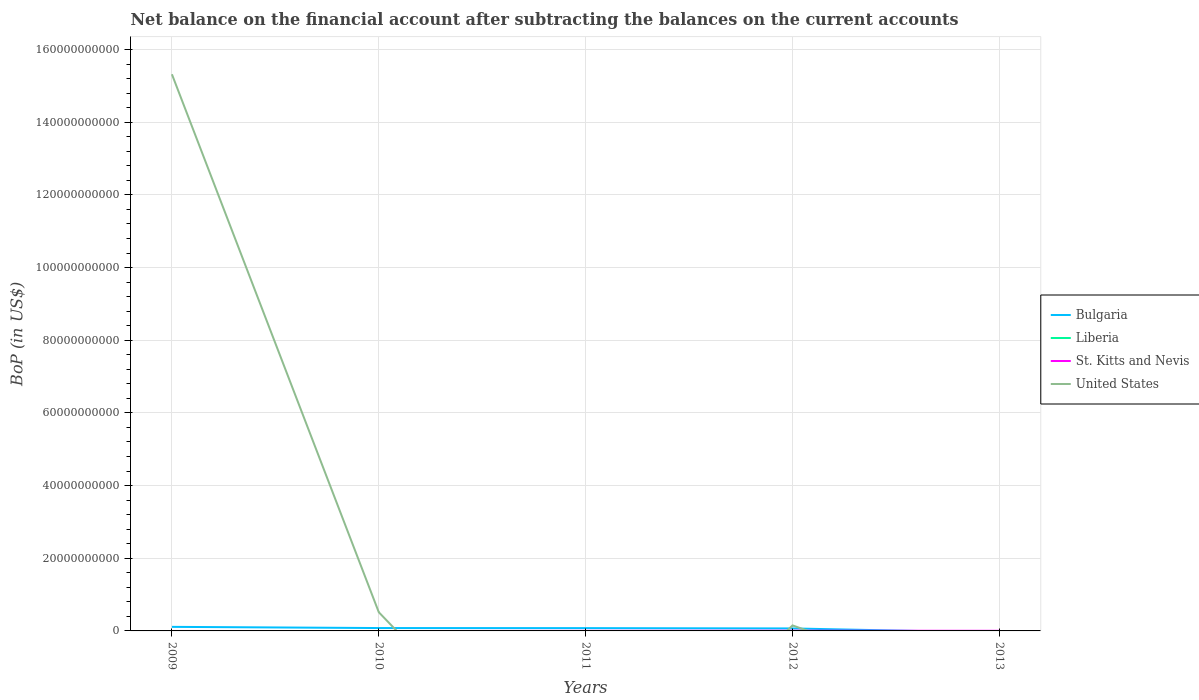How many different coloured lines are there?
Provide a short and direct response. 3. Is the number of lines equal to the number of legend labels?
Provide a succinct answer. No. What is the total Balance of Payments in Bulgaria in the graph?
Your response must be concise. 1.83e+07. What is the difference between the highest and the second highest Balance of Payments in United States?
Give a very brief answer. 1.53e+11. What is the difference between the highest and the lowest Balance of Payments in Liberia?
Offer a terse response. 0. Is the Balance of Payments in St. Kitts and Nevis strictly greater than the Balance of Payments in United States over the years?
Make the answer very short. No. How many lines are there?
Ensure brevity in your answer.  3. How many years are there in the graph?
Your answer should be very brief. 5. What is the difference between two consecutive major ticks on the Y-axis?
Make the answer very short. 2.00e+1. Does the graph contain any zero values?
Offer a very short reply. Yes. Where does the legend appear in the graph?
Ensure brevity in your answer.  Center right. How are the legend labels stacked?
Your answer should be compact. Vertical. What is the title of the graph?
Your answer should be compact. Net balance on the financial account after subtracting the balances on the current accounts. What is the label or title of the Y-axis?
Provide a short and direct response. BoP (in US$). What is the BoP (in US$) in Bulgaria in 2009?
Make the answer very short. 1.12e+09. What is the BoP (in US$) of Liberia in 2009?
Your answer should be very brief. 0. What is the BoP (in US$) in United States in 2009?
Your response must be concise. 1.53e+11. What is the BoP (in US$) in Bulgaria in 2010?
Make the answer very short. 7.89e+08. What is the BoP (in US$) of Liberia in 2010?
Ensure brevity in your answer.  0. What is the BoP (in US$) in United States in 2010?
Offer a very short reply. 5.15e+09. What is the BoP (in US$) of Bulgaria in 2011?
Provide a short and direct response. 7.71e+08. What is the BoP (in US$) of Liberia in 2011?
Ensure brevity in your answer.  0. What is the BoP (in US$) of St. Kitts and Nevis in 2011?
Your answer should be compact. 1.53e+07. What is the BoP (in US$) in Bulgaria in 2012?
Ensure brevity in your answer.  6.83e+08. What is the BoP (in US$) of St. Kitts and Nevis in 2012?
Ensure brevity in your answer.  5.53e+07. What is the BoP (in US$) of United States in 2012?
Provide a succinct answer. 1.52e+09. What is the BoP (in US$) of Bulgaria in 2013?
Provide a succinct answer. 0. What is the BoP (in US$) in Liberia in 2013?
Make the answer very short. 0. What is the BoP (in US$) in St. Kitts and Nevis in 2013?
Provide a short and direct response. 3.61e+07. Across all years, what is the maximum BoP (in US$) in Bulgaria?
Offer a terse response. 1.12e+09. Across all years, what is the maximum BoP (in US$) of St. Kitts and Nevis?
Give a very brief answer. 5.53e+07. Across all years, what is the maximum BoP (in US$) of United States?
Offer a very short reply. 1.53e+11. Across all years, what is the minimum BoP (in US$) in St. Kitts and Nevis?
Give a very brief answer. 0. What is the total BoP (in US$) in Bulgaria in the graph?
Offer a very short reply. 3.36e+09. What is the total BoP (in US$) of Liberia in the graph?
Ensure brevity in your answer.  0. What is the total BoP (in US$) of St. Kitts and Nevis in the graph?
Ensure brevity in your answer.  1.07e+08. What is the total BoP (in US$) of United States in the graph?
Offer a very short reply. 1.60e+11. What is the difference between the BoP (in US$) of Bulgaria in 2009 and that in 2010?
Give a very brief answer. 3.29e+08. What is the difference between the BoP (in US$) of United States in 2009 and that in 2010?
Give a very brief answer. 1.48e+11. What is the difference between the BoP (in US$) of Bulgaria in 2009 and that in 2011?
Your answer should be compact. 3.48e+08. What is the difference between the BoP (in US$) in Bulgaria in 2009 and that in 2012?
Ensure brevity in your answer.  4.35e+08. What is the difference between the BoP (in US$) in United States in 2009 and that in 2012?
Give a very brief answer. 1.52e+11. What is the difference between the BoP (in US$) of Bulgaria in 2010 and that in 2011?
Your answer should be compact. 1.83e+07. What is the difference between the BoP (in US$) in Bulgaria in 2010 and that in 2012?
Your response must be concise. 1.06e+08. What is the difference between the BoP (in US$) in United States in 2010 and that in 2012?
Your answer should be compact. 3.63e+09. What is the difference between the BoP (in US$) in Bulgaria in 2011 and that in 2012?
Your response must be concise. 8.74e+07. What is the difference between the BoP (in US$) of St. Kitts and Nevis in 2011 and that in 2012?
Offer a terse response. -4.00e+07. What is the difference between the BoP (in US$) in St. Kitts and Nevis in 2011 and that in 2013?
Give a very brief answer. -2.08e+07. What is the difference between the BoP (in US$) in St. Kitts and Nevis in 2012 and that in 2013?
Provide a short and direct response. 1.92e+07. What is the difference between the BoP (in US$) in Bulgaria in 2009 and the BoP (in US$) in United States in 2010?
Your answer should be compact. -4.03e+09. What is the difference between the BoP (in US$) of Bulgaria in 2009 and the BoP (in US$) of St. Kitts and Nevis in 2011?
Ensure brevity in your answer.  1.10e+09. What is the difference between the BoP (in US$) in Bulgaria in 2009 and the BoP (in US$) in St. Kitts and Nevis in 2012?
Provide a succinct answer. 1.06e+09. What is the difference between the BoP (in US$) of Bulgaria in 2009 and the BoP (in US$) of United States in 2012?
Offer a very short reply. -3.99e+08. What is the difference between the BoP (in US$) of Bulgaria in 2009 and the BoP (in US$) of St. Kitts and Nevis in 2013?
Your answer should be very brief. 1.08e+09. What is the difference between the BoP (in US$) of Bulgaria in 2010 and the BoP (in US$) of St. Kitts and Nevis in 2011?
Your response must be concise. 7.74e+08. What is the difference between the BoP (in US$) in Bulgaria in 2010 and the BoP (in US$) in St. Kitts and Nevis in 2012?
Make the answer very short. 7.34e+08. What is the difference between the BoP (in US$) of Bulgaria in 2010 and the BoP (in US$) of United States in 2012?
Your answer should be very brief. -7.28e+08. What is the difference between the BoP (in US$) of Bulgaria in 2010 and the BoP (in US$) of St. Kitts and Nevis in 2013?
Offer a very short reply. 7.53e+08. What is the difference between the BoP (in US$) of Bulgaria in 2011 and the BoP (in US$) of St. Kitts and Nevis in 2012?
Keep it short and to the point. 7.15e+08. What is the difference between the BoP (in US$) of Bulgaria in 2011 and the BoP (in US$) of United States in 2012?
Your answer should be very brief. -7.46e+08. What is the difference between the BoP (in US$) in St. Kitts and Nevis in 2011 and the BoP (in US$) in United States in 2012?
Provide a short and direct response. -1.50e+09. What is the difference between the BoP (in US$) of Bulgaria in 2011 and the BoP (in US$) of St. Kitts and Nevis in 2013?
Your response must be concise. 7.35e+08. What is the difference between the BoP (in US$) in Bulgaria in 2012 and the BoP (in US$) in St. Kitts and Nevis in 2013?
Make the answer very short. 6.47e+08. What is the average BoP (in US$) of Bulgaria per year?
Offer a terse response. 6.72e+08. What is the average BoP (in US$) of Liberia per year?
Provide a short and direct response. 0. What is the average BoP (in US$) of St. Kitts and Nevis per year?
Ensure brevity in your answer.  2.13e+07. What is the average BoP (in US$) in United States per year?
Offer a terse response. 3.20e+1. In the year 2009, what is the difference between the BoP (in US$) of Bulgaria and BoP (in US$) of United States?
Ensure brevity in your answer.  -1.52e+11. In the year 2010, what is the difference between the BoP (in US$) of Bulgaria and BoP (in US$) of United States?
Make the answer very short. -4.36e+09. In the year 2011, what is the difference between the BoP (in US$) of Bulgaria and BoP (in US$) of St. Kitts and Nevis?
Keep it short and to the point. 7.55e+08. In the year 2012, what is the difference between the BoP (in US$) of Bulgaria and BoP (in US$) of St. Kitts and Nevis?
Offer a terse response. 6.28e+08. In the year 2012, what is the difference between the BoP (in US$) in Bulgaria and BoP (in US$) in United States?
Keep it short and to the point. -8.34e+08. In the year 2012, what is the difference between the BoP (in US$) of St. Kitts and Nevis and BoP (in US$) of United States?
Give a very brief answer. -1.46e+09. What is the ratio of the BoP (in US$) of Bulgaria in 2009 to that in 2010?
Your answer should be compact. 1.42. What is the ratio of the BoP (in US$) in United States in 2009 to that in 2010?
Offer a very short reply. 29.76. What is the ratio of the BoP (in US$) in Bulgaria in 2009 to that in 2011?
Keep it short and to the point. 1.45. What is the ratio of the BoP (in US$) in Bulgaria in 2009 to that in 2012?
Offer a terse response. 1.64. What is the ratio of the BoP (in US$) in United States in 2009 to that in 2012?
Keep it short and to the point. 100.99. What is the ratio of the BoP (in US$) in Bulgaria in 2010 to that in 2011?
Your response must be concise. 1.02. What is the ratio of the BoP (in US$) of Bulgaria in 2010 to that in 2012?
Your answer should be very brief. 1.15. What is the ratio of the BoP (in US$) of United States in 2010 to that in 2012?
Offer a very short reply. 3.39. What is the ratio of the BoP (in US$) in Bulgaria in 2011 to that in 2012?
Your response must be concise. 1.13. What is the ratio of the BoP (in US$) of St. Kitts and Nevis in 2011 to that in 2012?
Make the answer very short. 0.28. What is the ratio of the BoP (in US$) in St. Kitts and Nevis in 2011 to that in 2013?
Your answer should be compact. 0.42. What is the ratio of the BoP (in US$) in St. Kitts and Nevis in 2012 to that in 2013?
Offer a very short reply. 1.53. What is the difference between the highest and the second highest BoP (in US$) of Bulgaria?
Provide a succinct answer. 3.29e+08. What is the difference between the highest and the second highest BoP (in US$) in St. Kitts and Nevis?
Keep it short and to the point. 1.92e+07. What is the difference between the highest and the second highest BoP (in US$) of United States?
Make the answer very short. 1.48e+11. What is the difference between the highest and the lowest BoP (in US$) in Bulgaria?
Give a very brief answer. 1.12e+09. What is the difference between the highest and the lowest BoP (in US$) of St. Kitts and Nevis?
Your answer should be very brief. 5.53e+07. What is the difference between the highest and the lowest BoP (in US$) of United States?
Make the answer very short. 1.53e+11. 